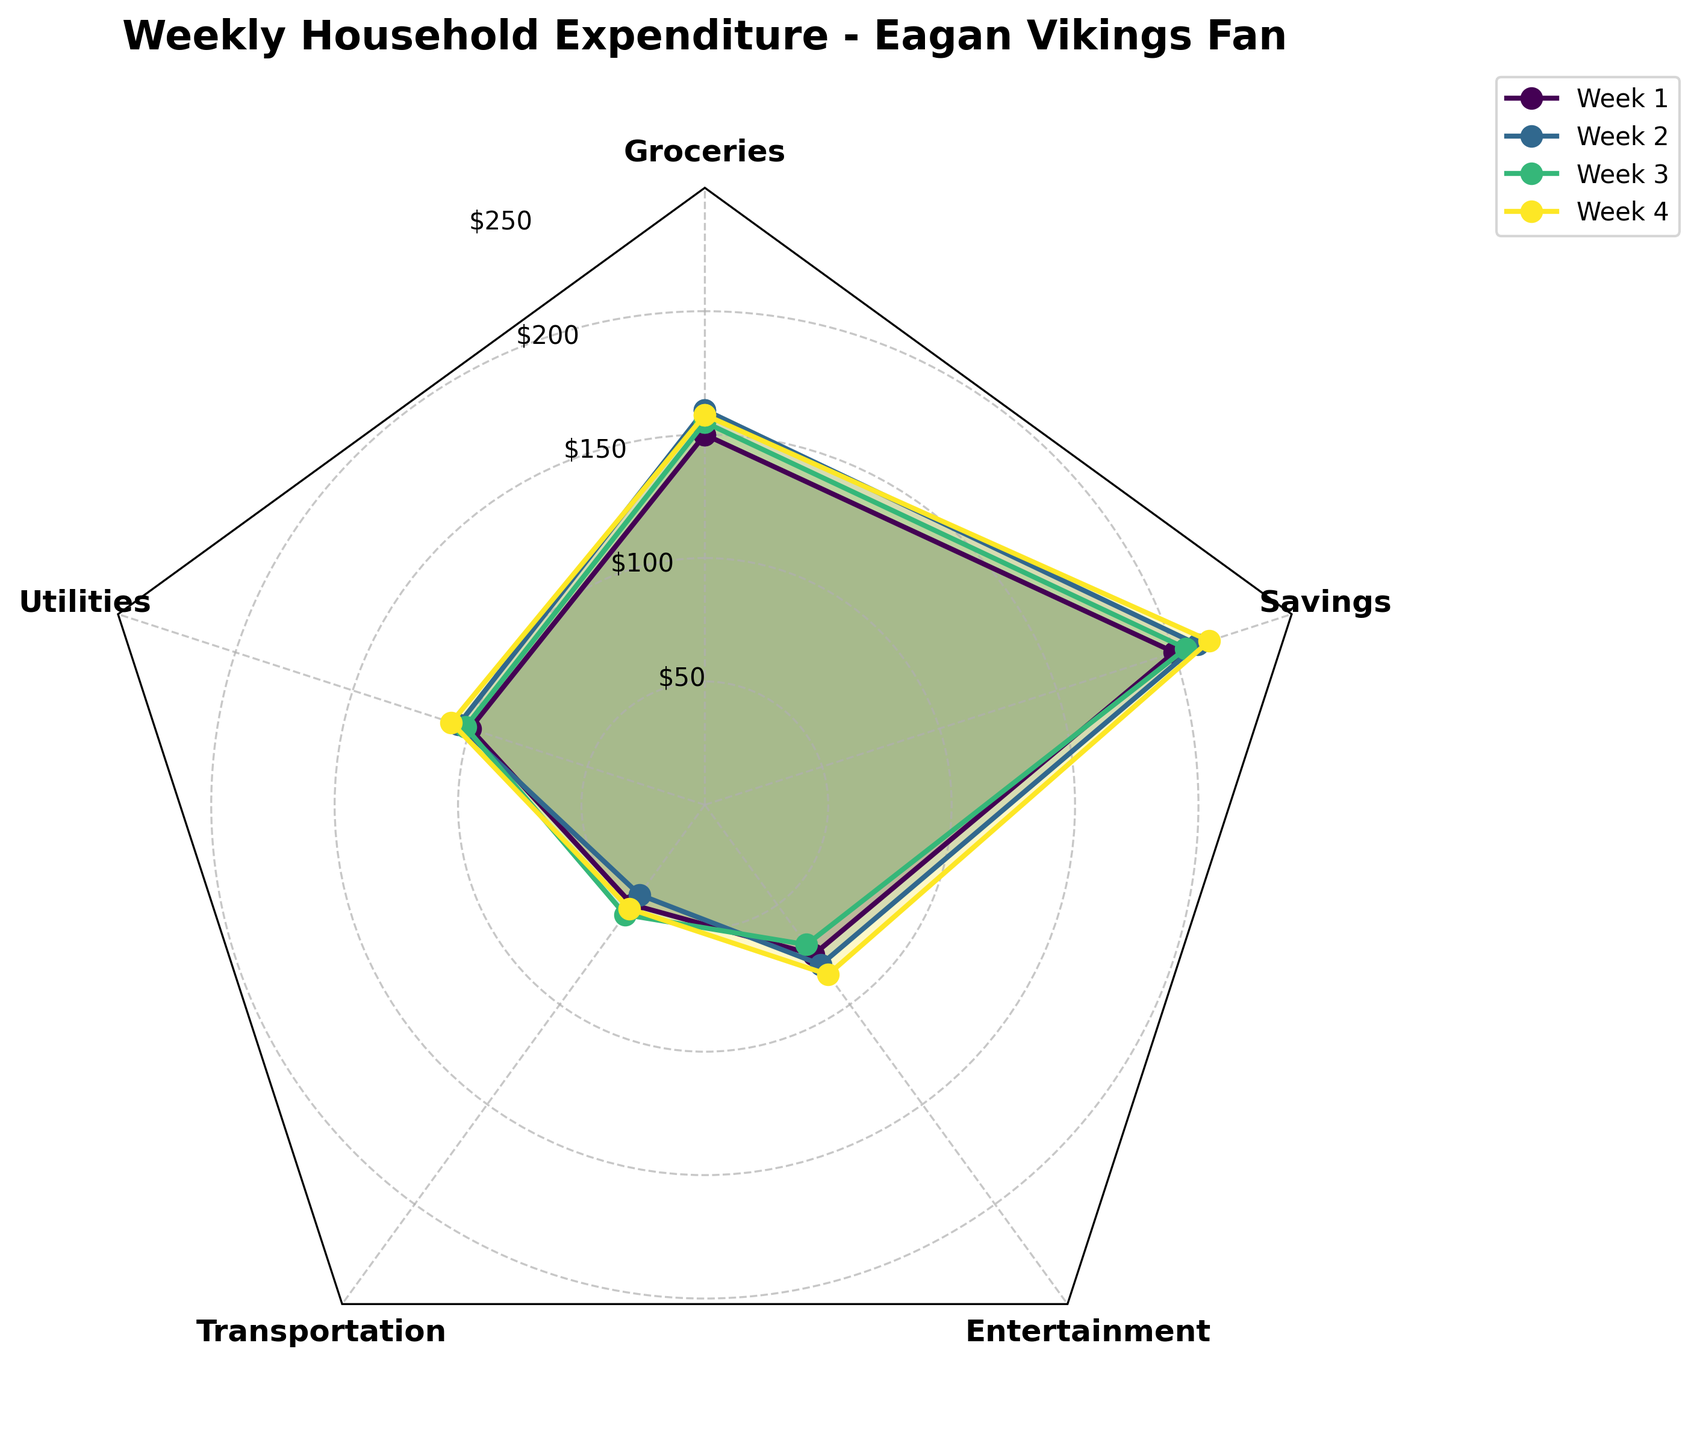How many categories of weekly household expenditures are displayed in the figure? The radar chart has several axes representing different categories. Counting these axes will reveal the number of categories.
Answer: 5 What are the different categories of household expenditures shown in the figure? The axes of the radar chart are labeled with the categories. These labels are the names of the expenditures.
Answer: Groceries, Utilities, Transportation, Entertainment, Savings Which week's household expenditures are the highest for Entertainment? Identify the point on the Entertainment axis for each week and compare their values to find the highest one.
Answer: Week 4 What is the average weekly expenditure on Groceries throughout the month? Locate the values for Groceries across the four weeks and calculate their average: (150 + 160 + 155 + 158) / 4.
Answer: 155.75 During which week was the expenditure on Utilities the second highest? Compare the Utilities expenditure across each week and find the week with the second highest value.
Answer: Week 2 Which expenditure category had the highest average over the four weeks? Calculate the average for each category over the four weeks and compare them to identify the highest: 
Groceries: (150 + 160 + 155 + 158) / 4 = 155.75
Utilities: (100 + 105 + 102 + 108) / 4 = 103.75
Transportation: (50 + 45 + 55 + 52) / 4 = 50.5
Entertainment: (75 + 80 + 70 + 85) / 4 = 77.5
Savings: (200 + 210 + 205 + 215) / 4 = 207.5.
Answer: Savings Which category saw the most fluctuation in expenditure over the four weeks? Calculate the range (max - min) for each category:
Groceries: 160 - 150 = 10
Utilities: 108 - 100 = 8
Transportation: 55 - 45 = 10
Entertainment: 85 - 70 = 15
Savings: 215 - 200 = 15.
Answer: Entertainment and Savings How does the expenditure on Transportation in Week 3 compare to Week 1? Find the values for Transportation in Week 3 and Week 1 and compare them: 55 (Week 3) vs. 50 (Week 1).
Answer: Week 3 is higher What is the total household expenditure for Week 4? Summing up each category's expenditure for Week 4: 158 (Groceries) + 108 (Utilities) + 52 (Transportation) + 85 (Entertainment) + 215 (Savings).
Answer: 618 Which category had the least average expenditure over the four weeks? Calculate the average for each category over the four weeks and identify the lowest:
Groceries: 155.75
Utilities: 103.75
Transportation: 50.5
Entertainment: 77.5
Savings: 207.5.
Answer: Transportation 